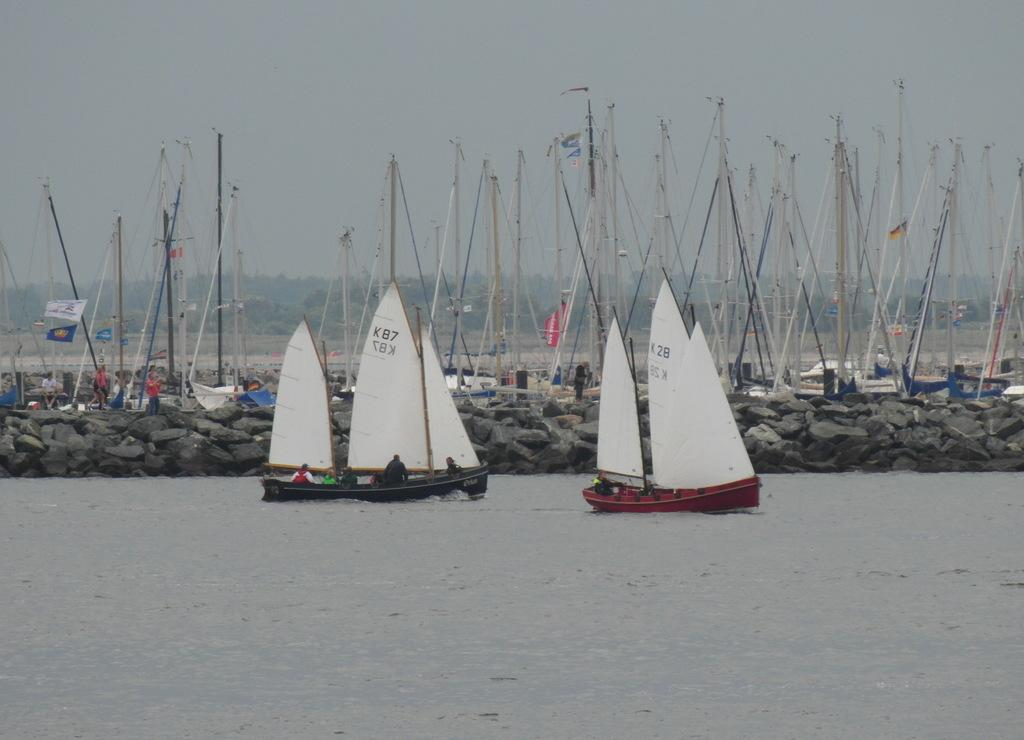What type of boats can be seen in the water? There are sail boats in the water. How many boats are visible in the image? There are many boats standing on the water. What type of crook can be seen in the image? There is no crook present in the image. Did an earthquake occur in the image? There is no indication of an earthquake in the image. 